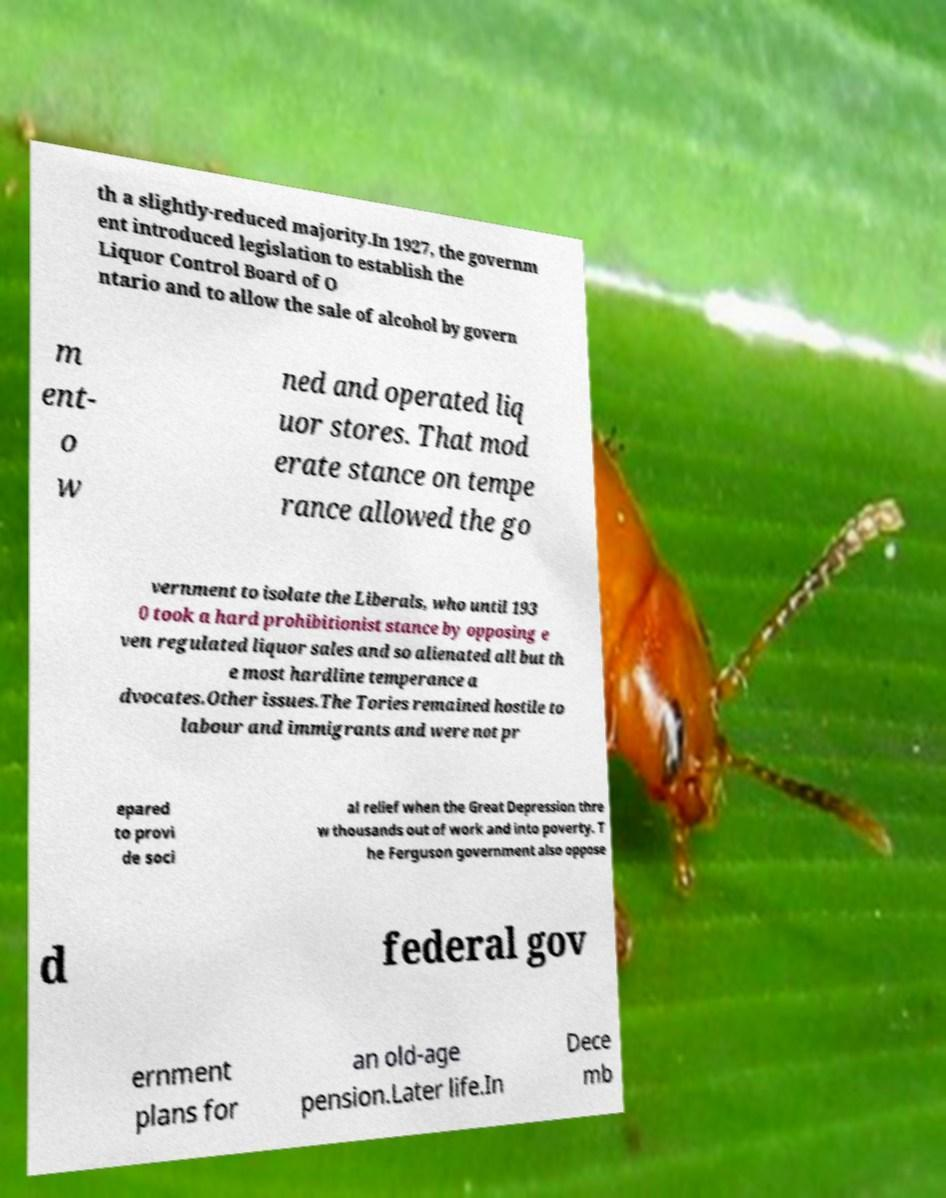What messages or text are displayed in this image? I need them in a readable, typed format. th a slightly-reduced majority.In 1927, the governm ent introduced legislation to establish the Liquor Control Board of O ntario and to allow the sale of alcohol by govern m ent- o w ned and operated liq uor stores. That mod erate stance on tempe rance allowed the go vernment to isolate the Liberals, who until 193 0 took a hard prohibitionist stance by opposing e ven regulated liquor sales and so alienated all but th e most hardline temperance a dvocates.Other issues.The Tories remained hostile to labour and immigrants and were not pr epared to provi de soci al relief when the Great Depression thre w thousands out of work and into poverty. T he Ferguson government also oppose d federal gov ernment plans for an old-age pension.Later life.In Dece mb 